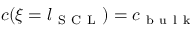<formula> <loc_0><loc_0><loc_500><loc_500>c ( \xi = l _ { S C L } ) = c _ { b u l k }</formula> 